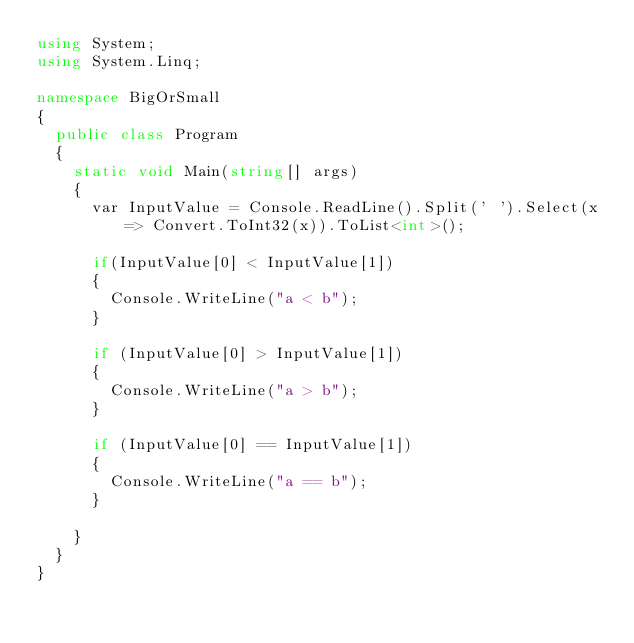<code> <loc_0><loc_0><loc_500><loc_500><_C#_>using System;
using System.Linq;

namespace BigOrSmall
{
	public class Program
	{
		static void Main(string[] args)
		{
			var InputValue = Console.ReadLine().Split(' ').Select(x => Convert.ToInt32(x)).ToList<int>();

			if(InputValue[0] < InputValue[1])
			{
				Console.WriteLine("a < b");
			}

			if (InputValue[0] > InputValue[1])
			{
				Console.WriteLine("a > b");
			}

			if (InputValue[0] == InputValue[1])
			{
				Console.WriteLine("a == b");
			}

		}
	}
}

</code> 